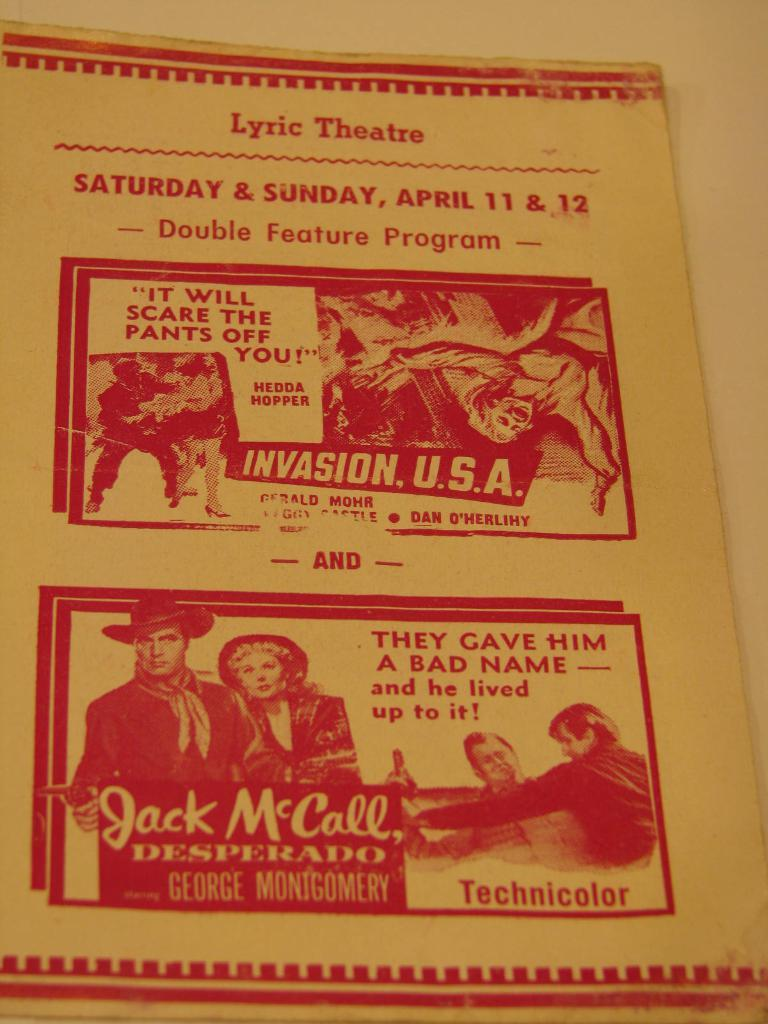<image>
Present a compact description of the photo's key features. A poster announcement for the Lyric Theatre and a show on Saturday and Sunday, April 11th and 12th which is a double feature. 